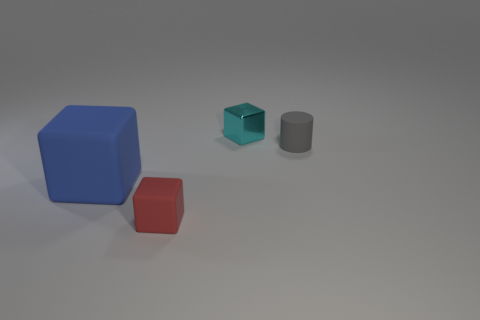Is there a big metallic ball? no 